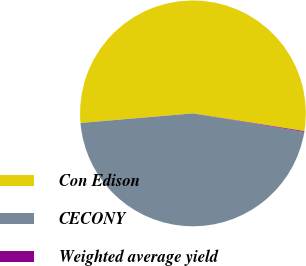<chart> <loc_0><loc_0><loc_500><loc_500><pie_chart><fcel>Con Edison<fcel>CECONY<fcel>Weighted average yield<nl><fcel>53.87%<fcel>46.02%<fcel>0.11%<nl></chart> 